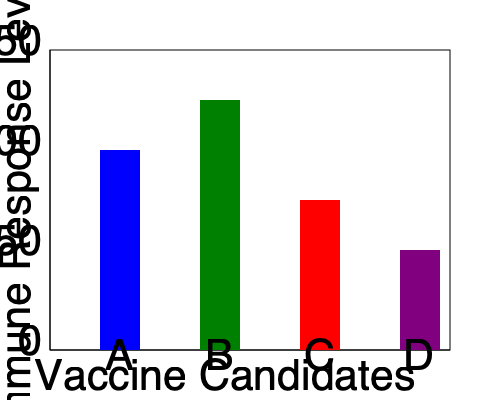Based on the bar chart showing immune response levels to various vaccine candidates, which candidate shows the highest potential for further development, and what is the approximate difference in immune response level between the top two candidates? To answer this question, we need to follow these steps:

1. Identify the vaccine candidate with the highest immune response level:
   - Candidate A: approximately 100 units
   - Candidate B: approximately 125 units
   - Candidate C: approximately 75 units
   - Candidate D: approximately 50 units

   Candidate B has the highest bar, indicating the highest immune response level.

2. Determine the second-highest immune response level:
   Candidate A has the second-highest bar.

3. Calculate the difference between the top two candidates:
   Difference = Immune response of B - Immune response of A
               ≈ 125 - 100 = 25 units

4. Interpret the results:
   Candidate B shows the highest potential for further development due to its superior immune response level. The approximate difference in immune response level between the top two candidates (B and A) is 25 units.

This analysis helps prioritize vaccine candidates for further research and development, focusing resources on the most promising options.
Answer: Candidate B; 25 units 